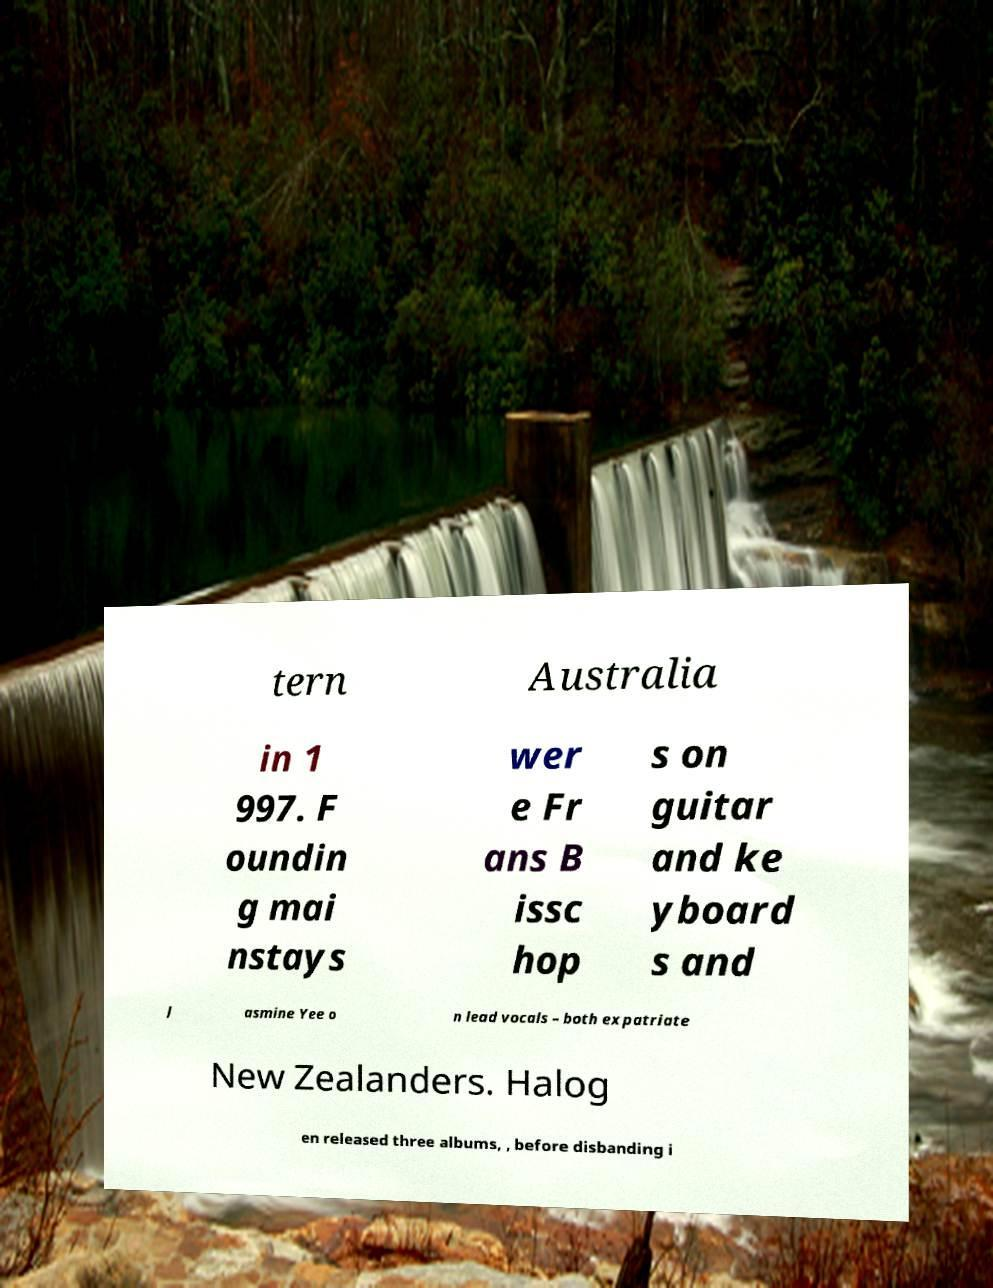I need the written content from this picture converted into text. Can you do that? tern Australia in 1 997. F oundin g mai nstays wer e Fr ans B issc hop s on guitar and ke yboard s and J asmine Yee o n lead vocals – both expatriate New Zealanders. Halog en released three albums, , before disbanding i 